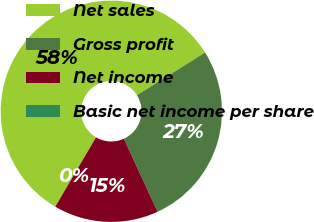Convert chart. <chart><loc_0><loc_0><loc_500><loc_500><pie_chart><fcel>Net sales<fcel>Gross profit<fcel>Net income<fcel>Basic net income per share<nl><fcel>57.65%<fcel>27.04%<fcel>15.31%<fcel>0.0%<nl></chart> 